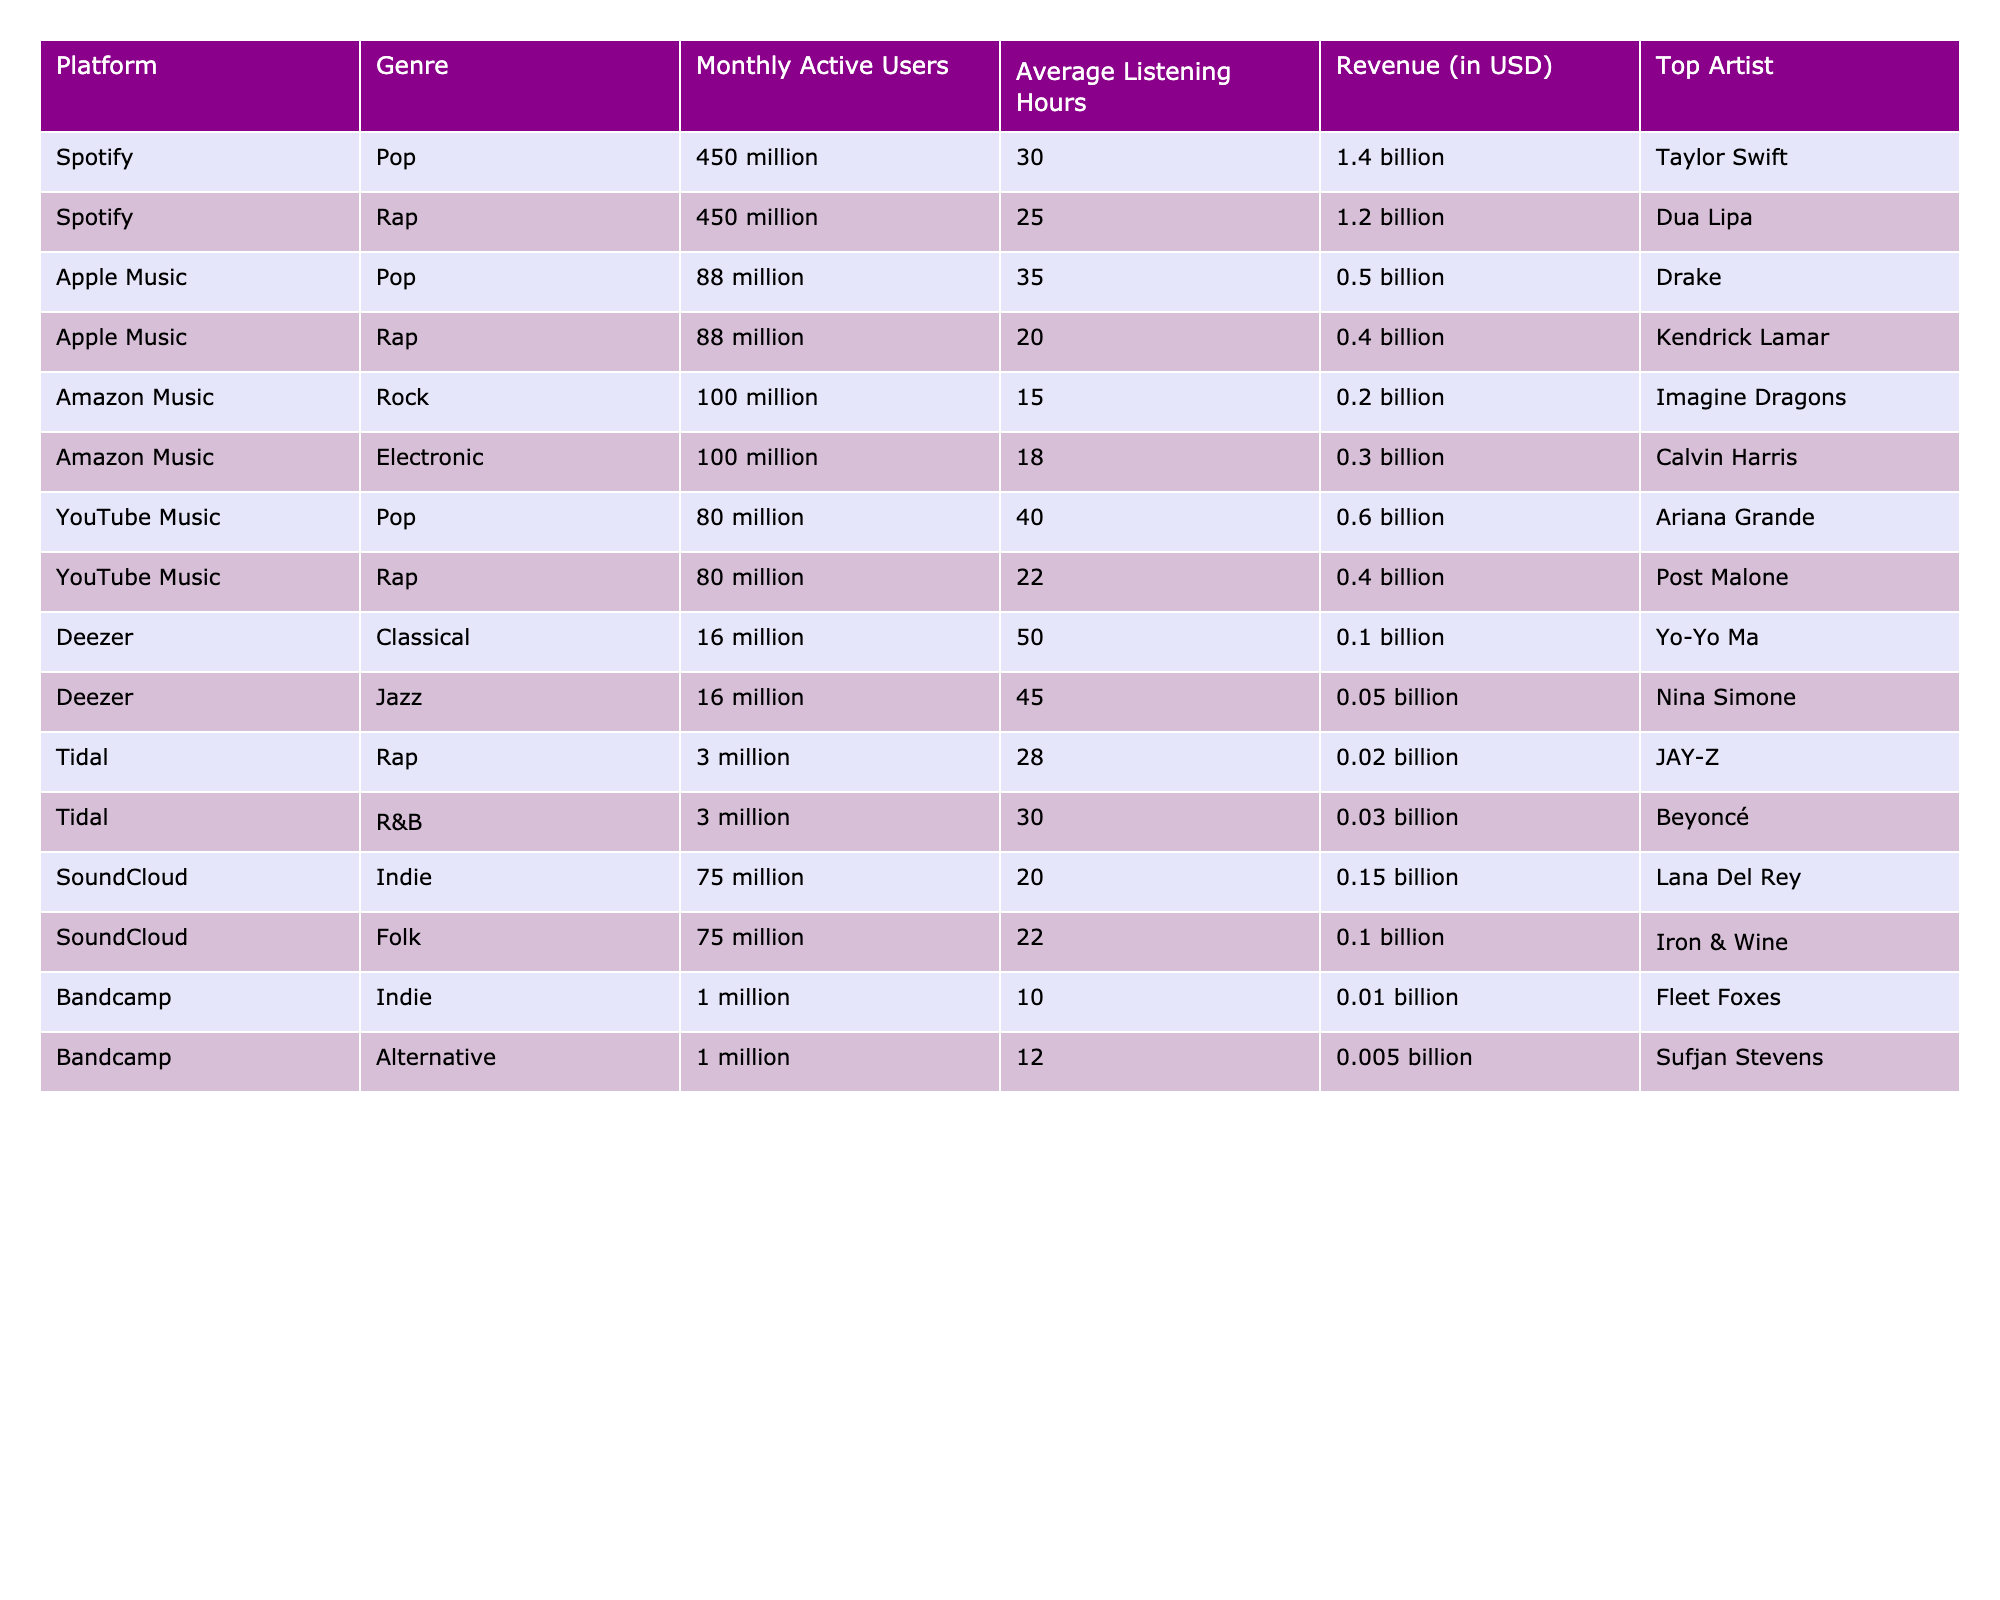What is the total revenue generated by Spotify for Pop and Rap genres combined? The revenue for Pop is 1.4 billion and for Rap is 1.2 billion. Adding these together gives 1.4 billion + 1.2 billion = 2.6 billion.
Answer: 2.6 billion Which platform has the highest average listening hours for the Pop genre? The average listening hours for Spotify is 30, for Apple Music is 35, and for YouTube Music is 40. Comparing these values, YouTube Music has the highest average listening hours of 40.
Answer: YouTube Music Is the average listening hours for Indie music on SoundCloud greater than on Bandcamp? For SoundCloud, the average listening hours for Indie is 20 and for Bandcamp, it is 10. Since 20 is greater than 10, the statement is true.
Answer: Yes What is the difference in monthly active users between Apple Music and Spotify for the Pop genre? For Pop, Spotify has 450 million active users, and Apple Music has 88 million. The difference is 450 million - 88 million = 362 million.
Answer: 362 million Which genre has the lowest revenue on Amazon Music? The revenue for Rock is 0.2 billion and for Electronic, it is 0.3 billion. Since 0.2 billion is lower, Rock has the lowest revenue on Amazon Music.
Answer: Rock Are there any platforms that report active users lower than 10 million? The data shows that Bandcamp reports 1 million active users, which is lower than 10 million, thereby confirming the statement is true.
Answer: Yes What is the average monthly listening hours across all genres on Deezer? The average listening hours for Classical is 50 and for Jazz is 45. The average is calculated as (50 + 45) / 2 = 47.5.
Answer: 47.5 Which platform has the highest revenue per monthly active user for the Rap genre? The revenue per active user for Spotify is 1.2 billion / 450 million = 2.67, for Apple Music it's 0.4 billion / 88 million = 4.55, and for Tidal it's 0.02 billion / 3 million = 6.67. Tidal has the highest value of 6.67.
Answer: Tidal What genre in SoundCloud has more average listening hours compared to Folk? The Indie genre has 20 hours while Folk has 22 hours. Therefore, no genre in SoundCloud has more average listening hours than Folk.
Answer: No Which top artist is associated with the highest revenue on YouTube Music? The revenue for Pop is 0.6 billion with Ariana Grande as the top artist, and for Rap, it is 0.4 billion with Post Malone. Since 0.6 billion is the highest, Ariana Grande is the associated artist.
Answer: Ariana Grande What is the average number of active users for the Indie genre across all platforms? The active users for Indie on SoundCloud is 75 million and on Bandcamp is 1 million. The average is (75 million + 1 million) / 2 = 38 million.
Answer: 38 million 